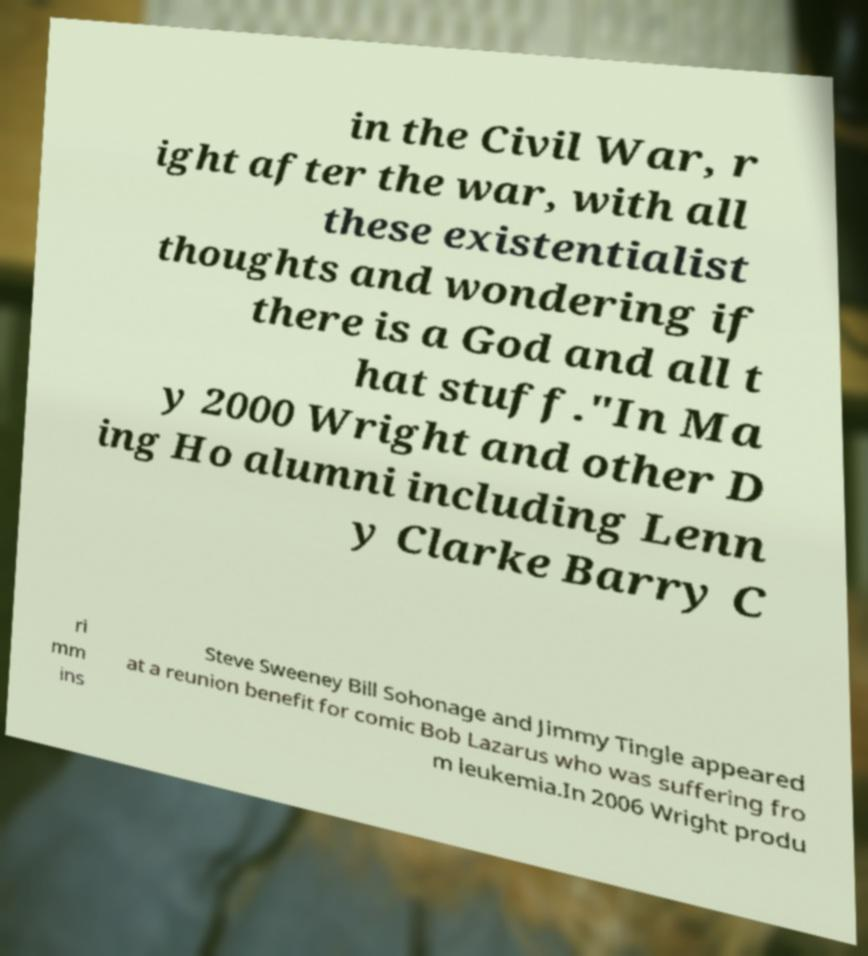Please identify and transcribe the text found in this image. in the Civil War, r ight after the war, with all these existentialist thoughts and wondering if there is a God and all t hat stuff."In Ma y 2000 Wright and other D ing Ho alumni including Lenn y Clarke Barry C ri mm ins Steve Sweeney Bill Sohonage and Jimmy Tingle appeared at a reunion benefit for comic Bob Lazarus who was suffering fro m leukemia.In 2006 Wright produ 